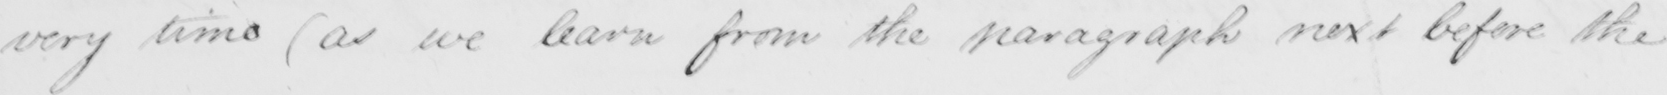What text is written in this handwritten line? very time  ( as we learn from the paragraph next before the 